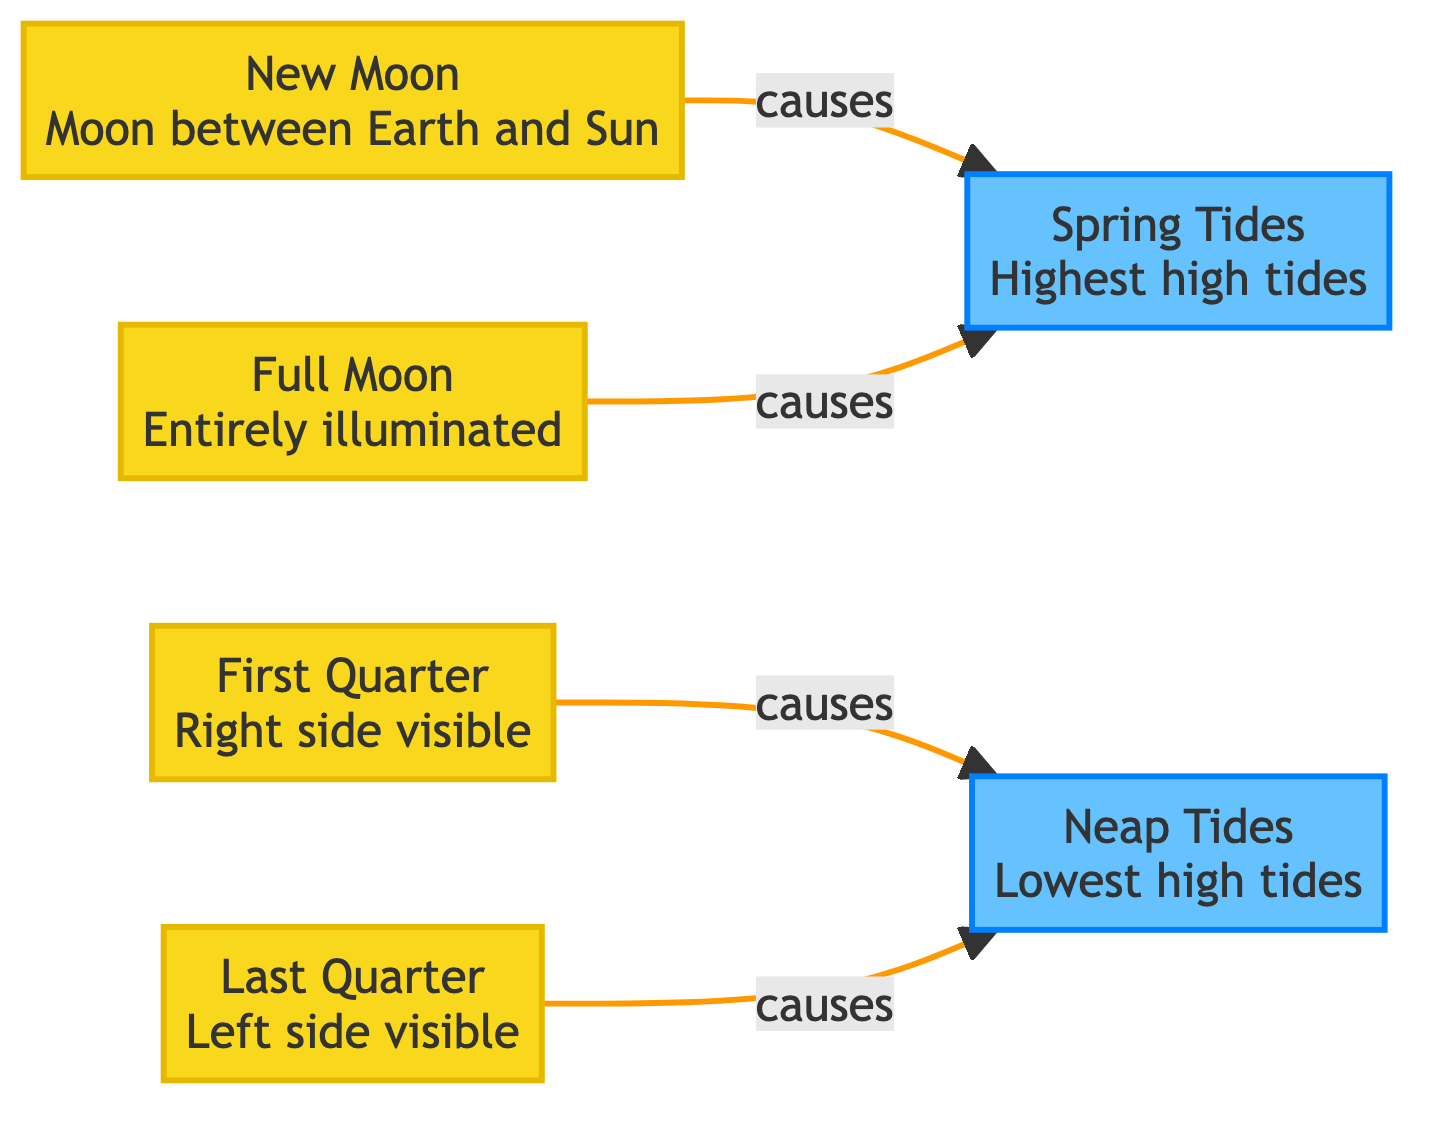What are the two phases that cause Spring Tides? In the diagram, Spring Tides are caused by New Moon and Full Moon phases. The relationships shown by the arrows indicate that both of these moon phases lead to Spring Tides.
Answer: New Moon and Full Moon Which phase causes Neap Tides? The diagram shows that Neap Tides are caused by First Quarter and Last Quarter phases. The arrows indicate these specific conditions lead to Neap Tides.
Answer: First Quarter and Last Quarter How many moon phases are shown in the diagram? By counting the distinct phases listed in the diagram, there are four: New Moon, First Quarter, Full Moon, and Last Quarter.
Answer: 4 What is the characteristic of Spring Tides? The diagram defines Spring Tides as having the highest high tides. This specific label attached to the Spring Tides node indicates its key feature.
Answer: Highest high tides Which moon phase has the right side visible? The diagram states that the First Quarter phase has the right side visible, as explicitly mentioned in the descriptive text next to that node.
Answer: First Quarter What do both Neap Tides and Spring Tides have in common? Analyzing the diagram, both Neap Tides and Spring Tides relate to the phases of the moon. They are both influenced directly by the position of the moon relative to the Earth and the Sun.
Answer: Both relate to moon phases Which phase is described as entirely illuminated? The Full Moon phase is described in the diagram as entirely illuminated, as indicated in the label of that specific node.
Answer: Full Moon What color represents the moon phases in the diagram? The moon phases are represented in yellow, as indicated by the class definition filled with the color #f9d71c in the diagram.
Answer: Yellow Which tides occur during the Full Moon? The diagram connects Full Moon directly to Spring Tides, implying that these tides occur during the Full Moon phase.
Answer: Spring Tides 